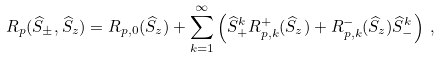Convert formula to latex. <formula><loc_0><loc_0><loc_500><loc_500>R _ { p } ( \widehat { S } _ { \pm } , \widehat { S } _ { z } ) = R _ { p , 0 } ( \widehat { S } _ { z } ) + \sum _ { k = 1 } ^ { \infty } \left ( \widehat { S } _ { + } ^ { k } R _ { p , k } ^ { + } ( \widehat { S } _ { z } ) + R _ { p , k } ^ { - } ( \widehat { S } _ { z } ) \widehat { S } _ { - } ^ { k } \right ) \, ,</formula> 